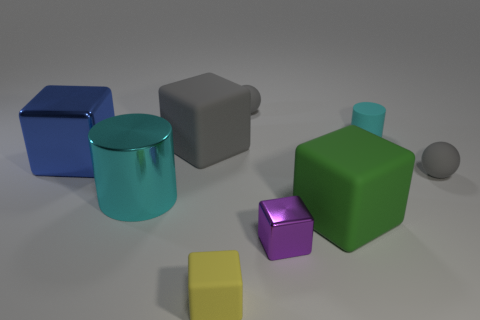Subtract all purple blocks. How many blocks are left? 4 Subtract all yellow blocks. How many blocks are left? 4 Add 1 green rubber spheres. How many objects exist? 10 Subtract all spheres. How many objects are left? 7 Subtract 1 gray blocks. How many objects are left? 8 Subtract 1 spheres. How many spheres are left? 1 Subtract all yellow cubes. Subtract all cyan cylinders. How many cubes are left? 4 Subtract all purple matte objects. Subtract all small cylinders. How many objects are left? 8 Add 1 big gray cubes. How many big gray cubes are left? 2 Add 8 large purple metal cylinders. How many large purple metal cylinders exist? 8 